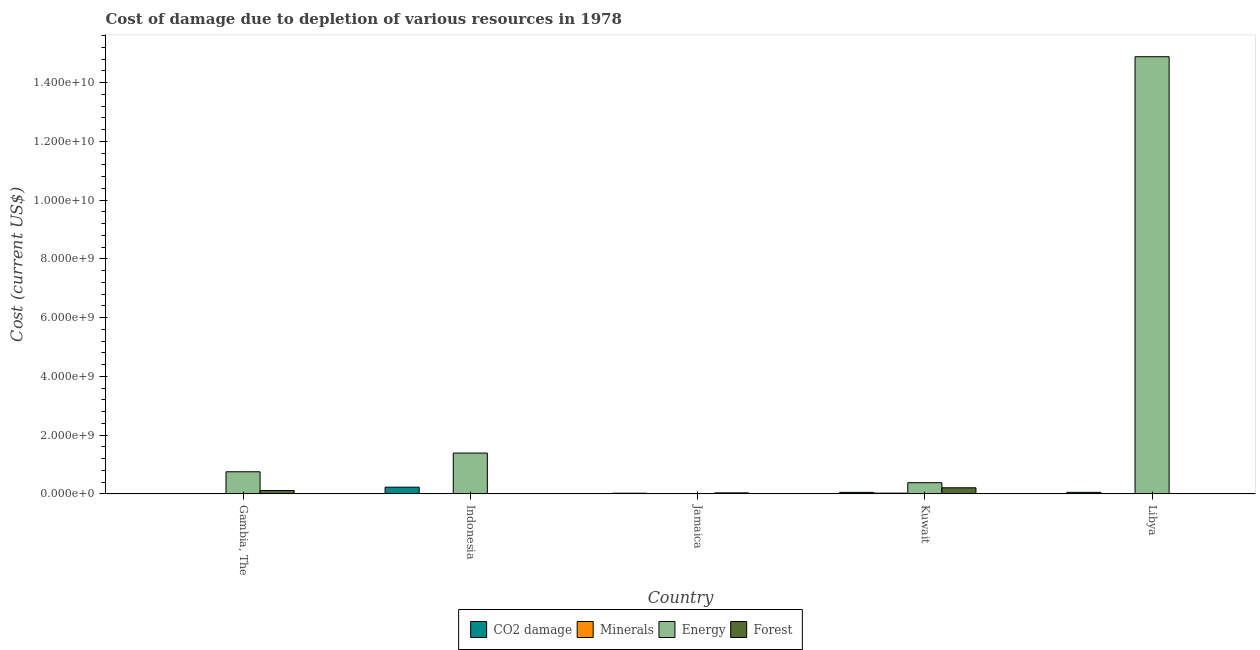Are the number of bars on each tick of the X-axis equal?
Give a very brief answer. Yes. What is the label of the 4th group of bars from the left?
Your response must be concise. Kuwait. What is the cost of damage due to depletion of minerals in Kuwait?
Ensure brevity in your answer.  2.48e+07. Across all countries, what is the maximum cost of damage due to depletion of forests?
Make the answer very short. 2.06e+08. Across all countries, what is the minimum cost of damage due to depletion of minerals?
Provide a succinct answer. 1.14e+05. In which country was the cost of damage due to depletion of energy maximum?
Make the answer very short. Libya. In which country was the cost of damage due to depletion of forests minimum?
Give a very brief answer. Libya. What is the total cost of damage due to depletion of coal in the graph?
Your answer should be compact. 3.52e+08. What is the difference between the cost of damage due to depletion of forests in Jamaica and that in Libya?
Provide a succinct answer. 3.29e+07. What is the difference between the cost of damage due to depletion of minerals in Libya and the cost of damage due to depletion of energy in Kuwait?
Your response must be concise. -3.73e+08. What is the average cost of damage due to depletion of forests per country?
Provide a short and direct response. 7.15e+07. What is the difference between the cost of damage due to depletion of coal and cost of damage due to depletion of minerals in Kuwait?
Make the answer very short. 2.60e+07. In how many countries, is the cost of damage due to depletion of minerals greater than 13200000000 US$?
Ensure brevity in your answer.  0. What is the ratio of the cost of damage due to depletion of forests in Jamaica to that in Libya?
Provide a short and direct response. 35.37. Is the cost of damage due to depletion of minerals in Jamaica less than that in Kuwait?
Give a very brief answer. Yes. Is the difference between the cost of damage due to depletion of minerals in Gambia, The and Libya greater than the difference between the cost of damage due to depletion of energy in Gambia, The and Libya?
Your answer should be very brief. Yes. What is the difference between the highest and the second highest cost of damage due to depletion of energy?
Offer a terse response. 1.35e+1. What is the difference between the highest and the lowest cost of damage due to depletion of minerals?
Offer a terse response. 2.47e+07. Is it the case that in every country, the sum of the cost of damage due to depletion of coal and cost of damage due to depletion of energy is greater than the sum of cost of damage due to depletion of minerals and cost of damage due to depletion of forests?
Provide a short and direct response. No. What does the 1st bar from the left in Gambia, The represents?
Offer a terse response. CO2 damage. What does the 4th bar from the right in Gambia, The represents?
Keep it short and to the point. CO2 damage. How many bars are there?
Your answer should be compact. 20. Are the values on the major ticks of Y-axis written in scientific E-notation?
Give a very brief answer. Yes. Does the graph contain any zero values?
Your response must be concise. No. How are the legend labels stacked?
Your response must be concise. Horizontal. What is the title of the graph?
Provide a short and direct response. Cost of damage due to depletion of various resources in 1978 . What is the label or title of the Y-axis?
Provide a succinct answer. Cost (current US$). What is the Cost (current US$) in CO2 damage in Gambia, The?
Provide a short and direct response. 3.37e+05. What is the Cost (current US$) of Minerals in Gambia, The?
Your answer should be compact. 1.14e+05. What is the Cost (current US$) of Energy in Gambia, The?
Your response must be concise. 7.52e+08. What is the Cost (current US$) in Forest in Gambia, The?
Ensure brevity in your answer.  1.15e+08. What is the Cost (current US$) in CO2 damage in Indonesia?
Give a very brief answer. 2.27e+08. What is the Cost (current US$) in Minerals in Indonesia?
Provide a succinct answer. 7.13e+06. What is the Cost (current US$) of Energy in Indonesia?
Your answer should be very brief. 1.39e+09. What is the Cost (current US$) of Forest in Indonesia?
Make the answer very short. 1.56e+06. What is the Cost (current US$) of CO2 damage in Jamaica?
Ensure brevity in your answer.  2.21e+07. What is the Cost (current US$) of Minerals in Jamaica?
Offer a very short reply. 2.74e+06. What is the Cost (current US$) in Energy in Jamaica?
Offer a very short reply. 1.10e+05. What is the Cost (current US$) of Forest in Jamaica?
Your answer should be very brief. 3.38e+07. What is the Cost (current US$) in CO2 damage in Kuwait?
Your answer should be compact. 5.08e+07. What is the Cost (current US$) of Minerals in Kuwait?
Your answer should be compact. 2.48e+07. What is the Cost (current US$) of Energy in Kuwait?
Keep it short and to the point. 3.80e+08. What is the Cost (current US$) of Forest in Kuwait?
Provide a short and direct response. 2.06e+08. What is the Cost (current US$) of CO2 damage in Libya?
Provide a succinct answer. 5.14e+07. What is the Cost (current US$) of Minerals in Libya?
Offer a very short reply. 6.87e+06. What is the Cost (current US$) of Energy in Libya?
Your answer should be compact. 1.49e+1. What is the Cost (current US$) of Forest in Libya?
Your answer should be very brief. 9.57e+05. Across all countries, what is the maximum Cost (current US$) of CO2 damage?
Your response must be concise. 2.27e+08. Across all countries, what is the maximum Cost (current US$) of Minerals?
Offer a very short reply. 2.48e+07. Across all countries, what is the maximum Cost (current US$) in Energy?
Offer a terse response. 1.49e+1. Across all countries, what is the maximum Cost (current US$) of Forest?
Give a very brief answer. 2.06e+08. Across all countries, what is the minimum Cost (current US$) in CO2 damage?
Ensure brevity in your answer.  3.37e+05. Across all countries, what is the minimum Cost (current US$) in Minerals?
Your answer should be compact. 1.14e+05. Across all countries, what is the minimum Cost (current US$) in Energy?
Make the answer very short. 1.10e+05. Across all countries, what is the minimum Cost (current US$) of Forest?
Provide a succinct answer. 9.57e+05. What is the total Cost (current US$) in CO2 damage in the graph?
Offer a terse response. 3.52e+08. What is the total Cost (current US$) of Minerals in the graph?
Give a very brief answer. 4.17e+07. What is the total Cost (current US$) of Energy in the graph?
Offer a very short reply. 1.74e+1. What is the total Cost (current US$) of Forest in the graph?
Provide a succinct answer. 3.57e+08. What is the difference between the Cost (current US$) in CO2 damage in Gambia, The and that in Indonesia?
Keep it short and to the point. -2.27e+08. What is the difference between the Cost (current US$) of Minerals in Gambia, The and that in Indonesia?
Offer a terse response. -7.01e+06. What is the difference between the Cost (current US$) in Energy in Gambia, The and that in Indonesia?
Provide a succinct answer. -6.37e+08. What is the difference between the Cost (current US$) of Forest in Gambia, The and that in Indonesia?
Give a very brief answer. 1.13e+08. What is the difference between the Cost (current US$) of CO2 damage in Gambia, The and that in Jamaica?
Provide a short and direct response. -2.17e+07. What is the difference between the Cost (current US$) in Minerals in Gambia, The and that in Jamaica?
Keep it short and to the point. -2.63e+06. What is the difference between the Cost (current US$) in Energy in Gambia, The and that in Jamaica?
Provide a succinct answer. 7.52e+08. What is the difference between the Cost (current US$) in Forest in Gambia, The and that in Jamaica?
Provide a short and direct response. 8.09e+07. What is the difference between the Cost (current US$) of CO2 damage in Gambia, The and that in Kuwait?
Make the answer very short. -5.05e+07. What is the difference between the Cost (current US$) in Minerals in Gambia, The and that in Kuwait?
Your answer should be compact. -2.47e+07. What is the difference between the Cost (current US$) of Energy in Gambia, The and that in Kuwait?
Provide a short and direct response. 3.72e+08. What is the difference between the Cost (current US$) in Forest in Gambia, The and that in Kuwait?
Provide a short and direct response. -9.16e+07. What is the difference between the Cost (current US$) in CO2 damage in Gambia, The and that in Libya?
Give a very brief answer. -5.10e+07. What is the difference between the Cost (current US$) of Minerals in Gambia, The and that in Libya?
Provide a short and direct response. -6.75e+06. What is the difference between the Cost (current US$) in Energy in Gambia, The and that in Libya?
Provide a short and direct response. -1.41e+1. What is the difference between the Cost (current US$) of Forest in Gambia, The and that in Libya?
Keep it short and to the point. 1.14e+08. What is the difference between the Cost (current US$) of CO2 damage in Indonesia and that in Jamaica?
Make the answer very short. 2.05e+08. What is the difference between the Cost (current US$) in Minerals in Indonesia and that in Jamaica?
Offer a terse response. 4.39e+06. What is the difference between the Cost (current US$) of Energy in Indonesia and that in Jamaica?
Provide a short and direct response. 1.39e+09. What is the difference between the Cost (current US$) of Forest in Indonesia and that in Jamaica?
Provide a succinct answer. -3.23e+07. What is the difference between the Cost (current US$) of CO2 damage in Indonesia and that in Kuwait?
Your response must be concise. 1.76e+08. What is the difference between the Cost (current US$) in Minerals in Indonesia and that in Kuwait?
Make the answer very short. -1.77e+07. What is the difference between the Cost (current US$) in Energy in Indonesia and that in Kuwait?
Provide a succinct answer. 1.01e+09. What is the difference between the Cost (current US$) of Forest in Indonesia and that in Kuwait?
Make the answer very short. -2.05e+08. What is the difference between the Cost (current US$) of CO2 damage in Indonesia and that in Libya?
Make the answer very short. 1.76e+08. What is the difference between the Cost (current US$) of Minerals in Indonesia and that in Libya?
Your response must be concise. 2.60e+05. What is the difference between the Cost (current US$) in Energy in Indonesia and that in Libya?
Ensure brevity in your answer.  -1.35e+1. What is the difference between the Cost (current US$) of Forest in Indonesia and that in Libya?
Offer a terse response. 6.05e+05. What is the difference between the Cost (current US$) in CO2 damage in Jamaica and that in Kuwait?
Your answer should be compact. -2.87e+07. What is the difference between the Cost (current US$) of Minerals in Jamaica and that in Kuwait?
Give a very brief answer. -2.21e+07. What is the difference between the Cost (current US$) in Energy in Jamaica and that in Kuwait?
Offer a terse response. -3.80e+08. What is the difference between the Cost (current US$) in Forest in Jamaica and that in Kuwait?
Make the answer very short. -1.72e+08. What is the difference between the Cost (current US$) in CO2 damage in Jamaica and that in Libya?
Your answer should be compact. -2.93e+07. What is the difference between the Cost (current US$) in Minerals in Jamaica and that in Libya?
Keep it short and to the point. -4.12e+06. What is the difference between the Cost (current US$) in Energy in Jamaica and that in Libya?
Give a very brief answer. -1.49e+1. What is the difference between the Cost (current US$) in Forest in Jamaica and that in Libya?
Ensure brevity in your answer.  3.29e+07. What is the difference between the Cost (current US$) of CO2 damage in Kuwait and that in Libya?
Keep it short and to the point. -5.76e+05. What is the difference between the Cost (current US$) of Minerals in Kuwait and that in Libya?
Make the answer very short. 1.79e+07. What is the difference between the Cost (current US$) in Energy in Kuwait and that in Libya?
Provide a short and direct response. -1.45e+1. What is the difference between the Cost (current US$) in Forest in Kuwait and that in Libya?
Offer a very short reply. 2.05e+08. What is the difference between the Cost (current US$) of CO2 damage in Gambia, The and the Cost (current US$) of Minerals in Indonesia?
Your response must be concise. -6.79e+06. What is the difference between the Cost (current US$) in CO2 damage in Gambia, The and the Cost (current US$) in Energy in Indonesia?
Keep it short and to the point. -1.39e+09. What is the difference between the Cost (current US$) in CO2 damage in Gambia, The and the Cost (current US$) in Forest in Indonesia?
Offer a terse response. -1.22e+06. What is the difference between the Cost (current US$) in Minerals in Gambia, The and the Cost (current US$) in Energy in Indonesia?
Make the answer very short. -1.39e+09. What is the difference between the Cost (current US$) in Minerals in Gambia, The and the Cost (current US$) in Forest in Indonesia?
Your answer should be very brief. -1.45e+06. What is the difference between the Cost (current US$) in Energy in Gambia, The and the Cost (current US$) in Forest in Indonesia?
Your answer should be very brief. 7.50e+08. What is the difference between the Cost (current US$) of CO2 damage in Gambia, The and the Cost (current US$) of Minerals in Jamaica?
Your response must be concise. -2.40e+06. What is the difference between the Cost (current US$) in CO2 damage in Gambia, The and the Cost (current US$) in Energy in Jamaica?
Ensure brevity in your answer.  2.27e+05. What is the difference between the Cost (current US$) in CO2 damage in Gambia, The and the Cost (current US$) in Forest in Jamaica?
Provide a short and direct response. -3.35e+07. What is the difference between the Cost (current US$) in Minerals in Gambia, The and the Cost (current US$) in Energy in Jamaica?
Provide a succinct answer. 4676.88. What is the difference between the Cost (current US$) in Minerals in Gambia, The and the Cost (current US$) in Forest in Jamaica?
Give a very brief answer. -3.37e+07. What is the difference between the Cost (current US$) in Energy in Gambia, The and the Cost (current US$) in Forest in Jamaica?
Give a very brief answer. 7.18e+08. What is the difference between the Cost (current US$) in CO2 damage in Gambia, The and the Cost (current US$) in Minerals in Kuwait?
Provide a succinct answer. -2.45e+07. What is the difference between the Cost (current US$) in CO2 damage in Gambia, The and the Cost (current US$) in Energy in Kuwait?
Ensure brevity in your answer.  -3.80e+08. What is the difference between the Cost (current US$) in CO2 damage in Gambia, The and the Cost (current US$) in Forest in Kuwait?
Provide a short and direct response. -2.06e+08. What is the difference between the Cost (current US$) in Minerals in Gambia, The and the Cost (current US$) in Energy in Kuwait?
Your response must be concise. -3.80e+08. What is the difference between the Cost (current US$) of Minerals in Gambia, The and the Cost (current US$) of Forest in Kuwait?
Offer a terse response. -2.06e+08. What is the difference between the Cost (current US$) of Energy in Gambia, The and the Cost (current US$) of Forest in Kuwait?
Give a very brief answer. 5.46e+08. What is the difference between the Cost (current US$) in CO2 damage in Gambia, The and the Cost (current US$) in Minerals in Libya?
Provide a short and direct response. -6.53e+06. What is the difference between the Cost (current US$) in CO2 damage in Gambia, The and the Cost (current US$) in Energy in Libya?
Your answer should be compact. -1.49e+1. What is the difference between the Cost (current US$) in CO2 damage in Gambia, The and the Cost (current US$) in Forest in Libya?
Provide a succinct answer. -6.20e+05. What is the difference between the Cost (current US$) in Minerals in Gambia, The and the Cost (current US$) in Energy in Libya?
Give a very brief answer. -1.49e+1. What is the difference between the Cost (current US$) of Minerals in Gambia, The and the Cost (current US$) of Forest in Libya?
Your response must be concise. -8.42e+05. What is the difference between the Cost (current US$) of Energy in Gambia, The and the Cost (current US$) of Forest in Libya?
Give a very brief answer. 7.51e+08. What is the difference between the Cost (current US$) of CO2 damage in Indonesia and the Cost (current US$) of Minerals in Jamaica?
Keep it short and to the point. 2.24e+08. What is the difference between the Cost (current US$) of CO2 damage in Indonesia and the Cost (current US$) of Energy in Jamaica?
Provide a succinct answer. 2.27e+08. What is the difference between the Cost (current US$) of CO2 damage in Indonesia and the Cost (current US$) of Forest in Jamaica?
Keep it short and to the point. 1.93e+08. What is the difference between the Cost (current US$) in Minerals in Indonesia and the Cost (current US$) in Energy in Jamaica?
Keep it short and to the point. 7.02e+06. What is the difference between the Cost (current US$) of Minerals in Indonesia and the Cost (current US$) of Forest in Jamaica?
Provide a short and direct response. -2.67e+07. What is the difference between the Cost (current US$) in Energy in Indonesia and the Cost (current US$) in Forest in Jamaica?
Your response must be concise. 1.35e+09. What is the difference between the Cost (current US$) in CO2 damage in Indonesia and the Cost (current US$) in Minerals in Kuwait?
Your response must be concise. 2.02e+08. What is the difference between the Cost (current US$) in CO2 damage in Indonesia and the Cost (current US$) in Energy in Kuwait?
Give a very brief answer. -1.53e+08. What is the difference between the Cost (current US$) in CO2 damage in Indonesia and the Cost (current US$) in Forest in Kuwait?
Offer a terse response. 2.09e+07. What is the difference between the Cost (current US$) in Minerals in Indonesia and the Cost (current US$) in Energy in Kuwait?
Keep it short and to the point. -3.73e+08. What is the difference between the Cost (current US$) of Minerals in Indonesia and the Cost (current US$) of Forest in Kuwait?
Make the answer very short. -1.99e+08. What is the difference between the Cost (current US$) in Energy in Indonesia and the Cost (current US$) in Forest in Kuwait?
Your answer should be very brief. 1.18e+09. What is the difference between the Cost (current US$) in CO2 damage in Indonesia and the Cost (current US$) in Minerals in Libya?
Keep it short and to the point. 2.20e+08. What is the difference between the Cost (current US$) in CO2 damage in Indonesia and the Cost (current US$) in Energy in Libya?
Make the answer very short. -1.47e+1. What is the difference between the Cost (current US$) in CO2 damage in Indonesia and the Cost (current US$) in Forest in Libya?
Give a very brief answer. 2.26e+08. What is the difference between the Cost (current US$) in Minerals in Indonesia and the Cost (current US$) in Energy in Libya?
Your answer should be compact. -1.49e+1. What is the difference between the Cost (current US$) of Minerals in Indonesia and the Cost (current US$) of Forest in Libya?
Offer a very short reply. 6.17e+06. What is the difference between the Cost (current US$) in Energy in Indonesia and the Cost (current US$) in Forest in Libya?
Keep it short and to the point. 1.39e+09. What is the difference between the Cost (current US$) of CO2 damage in Jamaica and the Cost (current US$) of Minerals in Kuwait?
Offer a terse response. -2.75e+06. What is the difference between the Cost (current US$) in CO2 damage in Jamaica and the Cost (current US$) in Energy in Kuwait?
Keep it short and to the point. -3.58e+08. What is the difference between the Cost (current US$) in CO2 damage in Jamaica and the Cost (current US$) in Forest in Kuwait?
Provide a succinct answer. -1.84e+08. What is the difference between the Cost (current US$) in Minerals in Jamaica and the Cost (current US$) in Energy in Kuwait?
Provide a succinct answer. -3.77e+08. What is the difference between the Cost (current US$) in Minerals in Jamaica and the Cost (current US$) in Forest in Kuwait?
Make the answer very short. -2.04e+08. What is the difference between the Cost (current US$) of Energy in Jamaica and the Cost (current US$) of Forest in Kuwait?
Provide a succinct answer. -2.06e+08. What is the difference between the Cost (current US$) in CO2 damage in Jamaica and the Cost (current US$) in Minerals in Libya?
Ensure brevity in your answer.  1.52e+07. What is the difference between the Cost (current US$) in CO2 damage in Jamaica and the Cost (current US$) in Energy in Libya?
Your answer should be very brief. -1.49e+1. What is the difference between the Cost (current US$) of CO2 damage in Jamaica and the Cost (current US$) of Forest in Libya?
Offer a very short reply. 2.11e+07. What is the difference between the Cost (current US$) in Minerals in Jamaica and the Cost (current US$) in Energy in Libya?
Your response must be concise. -1.49e+1. What is the difference between the Cost (current US$) of Minerals in Jamaica and the Cost (current US$) of Forest in Libya?
Your answer should be compact. 1.78e+06. What is the difference between the Cost (current US$) of Energy in Jamaica and the Cost (current US$) of Forest in Libya?
Make the answer very short. -8.47e+05. What is the difference between the Cost (current US$) of CO2 damage in Kuwait and the Cost (current US$) of Minerals in Libya?
Keep it short and to the point. 4.39e+07. What is the difference between the Cost (current US$) of CO2 damage in Kuwait and the Cost (current US$) of Energy in Libya?
Offer a terse response. -1.48e+1. What is the difference between the Cost (current US$) in CO2 damage in Kuwait and the Cost (current US$) in Forest in Libya?
Ensure brevity in your answer.  4.98e+07. What is the difference between the Cost (current US$) in Minerals in Kuwait and the Cost (current US$) in Energy in Libya?
Provide a short and direct response. -1.49e+1. What is the difference between the Cost (current US$) of Minerals in Kuwait and the Cost (current US$) of Forest in Libya?
Your answer should be very brief. 2.38e+07. What is the difference between the Cost (current US$) in Energy in Kuwait and the Cost (current US$) in Forest in Libya?
Your answer should be very brief. 3.79e+08. What is the average Cost (current US$) of CO2 damage per country?
Offer a terse response. 7.04e+07. What is the average Cost (current US$) in Minerals per country?
Offer a terse response. 8.33e+06. What is the average Cost (current US$) of Energy per country?
Give a very brief answer. 3.48e+09. What is the average Cost (current US$) in Forest per country?
Make the answer very short. 7.15e+07. What is the difference between the Cost (current US$) of CO2 damage and Cost (current US$) of Minerals in Gambia, The?
Offer a terse response. 2.23e+05. What is the difference between the Cost (current US$) of CO2 damage and Cost (current US$) of Energy in Gambia, The?
Ensure brevity in your answer.  -7.52e+08. What is the difference between the Cost (current US$) of CO2 damage and Cost (current US$) of Forest in Gambia, The?
Ensure brevity in your answer.  -1.14e+08. What is the difference between the Cost (current US$) of Minerals and Cost (current US$) of Energy in Gambia, The?
Ensure brevity in your answer.  -7.52e+08. What is the difference between the Cost (current US$) in Minerals and Cost (current US$) in Forest in Gambia, The?
Your response must be concise. -1.15e+08. What is the difference between the Cost (current US$) in Energy and Cost (current US$) in Forest in Gambia, The?
Your answer should be compact. 6.37e+08. What is the difference between the Cost (current US$) in CO2 damage and Cost (current US$) in Minerals in Indonesia?
Provide a short and direct response. 2.20e+08. What is the difference between the Cost (current US$) in CO2 damage and Cost (current US$) in Energy in Indonesia?
Keep it short and to the point. -1.16e+09. What is the difference between the Cost (current US$) in CO2 damage and Cost (current US$) in Forest in Indonesia?
Give a very brief answer. 2.26e+08. What is the difference between the Cost (current US$) in Minerals and Cost (current US$) in Energy in Indonesia?
Provide a short and direct response. -1.38e+09. What is the difference between the Cost (current US$) in Minerals and Cost (current US$) in Forest in Indonesia?
Your answer should be very brief. 5.56e+06. What is the difference between the Cost (current US$) of Energy and Cost (current US$) of Forest in Indonesia?
Ensure brevity in your answer.  1.39e+09. What is the difference between the Cost (current US$) of CO2 damage and Cost (current US$) of Minerals in Jamaica?
Your response must be concise. 1.93e+07. What is the difference between the Cost (current US$) of CO2 damage and Cost (current US$) of Energy in Jamaica?
Provide a succinct answer. 2.19e+07. What is the difference between the Cost (current US$) of CO2 damage and Cost (current US$) of Forest in Jamaica?
Ensure brevity in your answer.  -1.18e+07. What is the difference between the Cost (current US$) of Minerals and Cost (current US$) of Energy in Jamaica?
Ensure brevity in your answer.  2.63e+06. What is the difference between the Cost (current US$) in Minerals and Cost (current US$) in Forest in Jamaica?
Offer a terse response. -3.11e+07. What is the difference between the Cost (current US$) of Energy and Cost (current US$) of Forest in Jamaica?
Ensure brevity in your answer.  -3.37e+07. What is the difference between the Cost (current US$) of CO2 damage and Cost (current US$) of Minerals in Kuwait?
Keep it short and to the point. 2.60e+07. What is the difference between the Cost (current US$) of CO2 damage and Cost (current US$) of Energy in Kuwait?
Provide a short and direct response. -3.29e+08. What is the difference between the Cost (current US$) of CO2 damage and Cost (current US$) of Forest in Kuwait?
Offer a terse response. -1.55e+08. What is the difference between the Cost (current US$) of Minerals and Cost (current US$) of Energy in Kuwait?
Your answer should be compact. -3.55e+08. What is the difference between the Cost (current US$) in Minerals and Cost (current US$) in Forest in Kuwait?
Offer a very short reply. -1.81e+08. What is the difference between the Cost (current US$) of Energy and Cost (current US$) of Forest in Kuwait?
Your response must be concise. 1.74e+08. What is the difference between the Cost (current US$) in CO2 damage and Cost (current US$) in Minerals in Libya?
Offer a terse response. 4.45e+07. What is the difference between the Cost (current US$) of CO2 damage and Cost (current US$) of Energy in Libya?
Make the answer very short. -1.48e+1. What is the difference between the Cost (current US$) in CO2 damage and Cost (current US$) in Forest in Libya?
Keep it short and to the point. 5.04e+07. What is the difference between the Cost (current US$) in Minerals and Cost (current US$) in Energy in Libya?
Make the answer very short. -1.49e+1. What is the difference between the Cost (current US$) in Minerals and Cost (current US$) in Forest in Libya?
Keep it short and to the point. 5.91e+06. What is the difference between the Cost (current US$) in Energy and Cost (current US$) in Forest in Libya?
Your answer should be very brief. 1.49e+1. What is the ratio of the Cost (current US$) of CO2 damage in Gambia, The to that in Indonesia?
Your answer should be very brief. 0. What is the ratio of the Cost (current US$) in Minerals in Gambia, The to that in Indonesia?
Offer a terse response. 0.02. What is the ratio of the Cost (current US$) of Energy in Gambia, The to that in Indonesia?
Provide a short and direct response. 0.54. What is the ratio of the Cost (current US$) in Forest in Gambia, The to that in Indonesia?
Make the answer very short. 73.43. What is the ratio of the Cost (current US$) of CO2 damage in Gambia, The to that in Jamaica?
Make the answer very short. 0.02. What is the ratio of the Cost (current US$) of Minerals in Gambia, The to that in Jamaica?
Offer a very short reply. 0.04. What is the ratio of the Cost (current US$) in Energy in Gambia, The to that in Jamaica?
Your answer should be very brief. 6849.23. What is the ratio of the Cost (current US$) in Forest in Gambia, The to that in Jamaica?
Make the answer very short. 3.39. What is the ratio of the Cost (current US$) in CO2 damage in Gambia, The to that in Kuwait?
Give a very brief answer. 0.01. What is the ratio of the Cost (current US$) of Minerals in Gambia, The to that in Kuwait?
Make the answer very short. 0. What is the ratio of the Cost (current US$) in Energy in Gambia, The to that in Kuwait?
Provide a short and direct response. 1.98. What is the ratio of the Cost (current US$) of Forest in Gambia, The to that in Kuwait?
Your answer should be compact. 0.56. What is the ratio of the Cost (current US$) of CO2 damage in Gambia, The to that in Libya?
Ensure brevity in your answer.  0.01. What is the ratio of the Cost (current US$) in Minerals in Gambia, The to that in Libya?
Offer a terse response. 0.02. What is the ratio of the Cost (current US$) of Energy in Gambia, The to that in Libya?
Provide a short and direct response. 0.05. What is the ratio of the Cost (current US$) in Forest in Gambia, The to that in Libya?
Your answer should be very brief. 119.87. What is the ratio of the Cost (current US$) of Minerals in Indonesia to that in Jamaica?
Your answer should be very brief. 2.6. What is the ratio of the Cost (current US$) of Energy in Indonesia to that in Jamaica?
Your answer should be compact. 1.26e+04. What is the ratio of the Cost (current US$) of Forest in Indonesia to that in Jamaica?
Give a very brief answer. 0.05. What is the ratio of the Cost (current US$) in CO2 damage in Indonesia to that in Kuwait?
Your answer should be compact. 4.47. What is the ratio of the Cost (current US$) of Minerals in Indonesia to that in Kuwait?
Your response must be concise. 0.29. What is the ratio of the Cost (current US$) of Energy in Indonesia to that in Kuwait?
Give a very brief answer. 3.66. What is the ratio of the Cost (current US$) in Forest in Indonesia to that in Kuwait?
Your response must be concise. 0.01. What is the ratio of the Cost (current US$) of CO2 damage in Indonesia to that in Libya?
Your answer should be compact. 4.42. What is the ratio of the Cost (current US$) of Minerals in Indonesia to that in Libya?
Your response must be concise. 1.04. What is the ratio of the Cost (current US$) in Energy in Indonesia to that in Libya?
Your response must be concise. 0.09. What is the ratio of the Cost (current US$) in Forest in Indonesia to that in Libya?
Offer a terse response. 1.63. What is the ratio of the Cost (current US$) in CO2 damage in Jamaica to that in Kuwait?
Give a very brief answer. 0.43. What is the ratio of the Cost (current US$) in Minerals in Jamaica to that in Kuwait?
Offer a terse response. 0.11. What is the ratio of the Cost (current US$) of Energy in Jamaica to that in Kuwait?
Provide a short and direct response. 0. What is the ratio of the Cost (current US$) in Forest in Jamaica to that in Kuwait?
Offer a very short reply. 0.16. What is the ratio of the Cost (current US$) in CO2 damage in Jamaica to that in Libya?
Provide a short and direct response. 0.43. What is the ratio of the Cost (current US$) in Minerals in Jamaica to that in Libya?
Ensure brevity in your answer.  0.4. What is the ratio of the Cost (current US$) in Forest in Jamaica to that in Libya?
Keep it short and to the point. 35.37. What is the ratio of the Cost (current US$) in CO2 damage in Kuwait to that in Libya?
Keep it short and to the point. 0.99. What is the ratio of the Cost (current US$) in Minerals in Kuwait to that in Libya?
Keep it short and to the point. 3.61. What is the ratio of the Cost (current US$) in Energy in Kuwait to that in Libya?
Your answer should be compact. 0.03. What is the ratio of the Cost (current US$) in Forest in Kuwait to that in Libya?
Provide a succinct answer. 215.58. What is the difference between the highest and the second highest Cost (current US$) in CO2 damage?
Your answer should be very brief. 1.76e+08. What is the difference between the highest and the second highest Cost (current US$) of Minerals?
Make the answer very short. 1.77e+07. What is the difference between the highest and the second highest Cost (current US$) in Energy?
Your answer should be compact. 1.35e+1. What is the difference between the highest and the second highest Cost (current US$) of Forest?
Make the answer very short. 9.16e+07. What is the difference between the highest and the lowest Cost (current US$) in CO2 damage?
Your response must be concise. 2.27e+08. What is the difference between the highest and the lowest Cost (current US$) of Minerals?
Your answer should be very brief. 2.47e+07. What is the difference between the highest and the lowest Cost (current US$) in Energy?
Give a very brief answer. 1.49e+1. What is the difference between the highest and the lowest Cost (current US$) of Forest?
Offer a very short reply. 2.05e+08. 